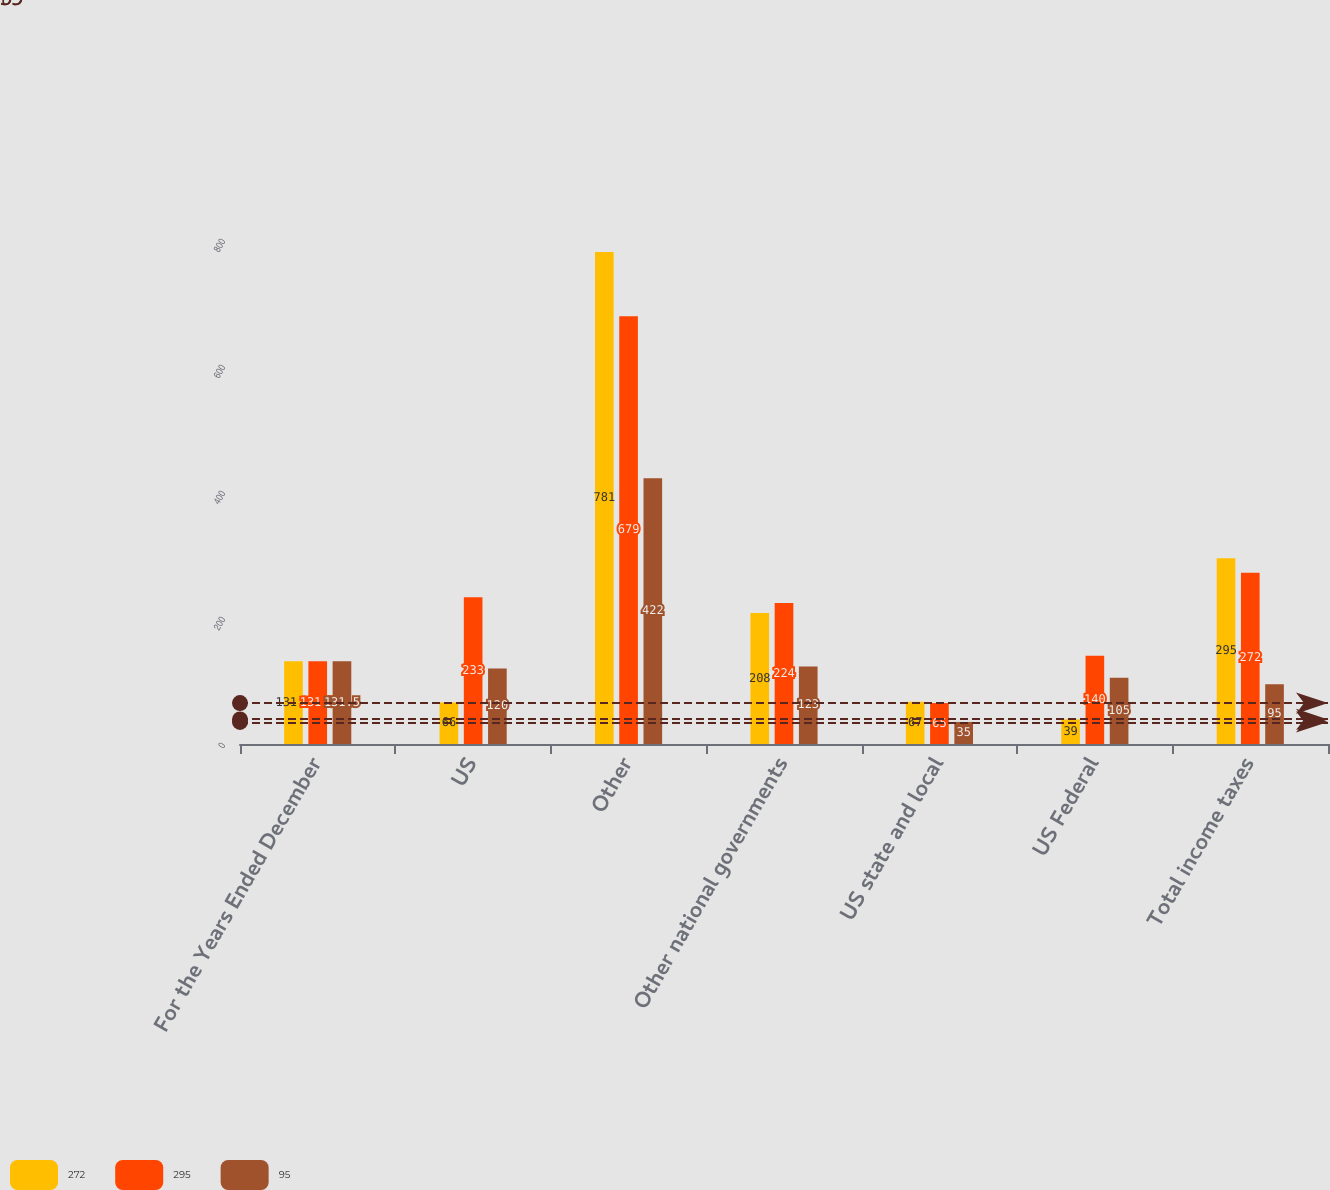<chart> <loc_0><loc_0><loc_500><loc_500><stacked_bar_chart><ecel><fcel>For the Years Ended December<fcel>US<fcel>Other<fcel>Other national governments<fcel>US state and local<fcel>US Federal<fcel>Total income taxes<nl><fcel>272<fcel>131.5<fcel>66<fcel>781<fcel>208<fcel>67<fcel>39<fcel>295<nl><fcel>295<fcel>131.5<fcel>233<fcel>679<fcel>224<fcel>65<fcel>140<fcel>272<nl><fcel>95<fcel>131.5<fcel>120<fcel>422<fcel>123<fcel>35<fcel>105<fcel>95<nl></chart> 